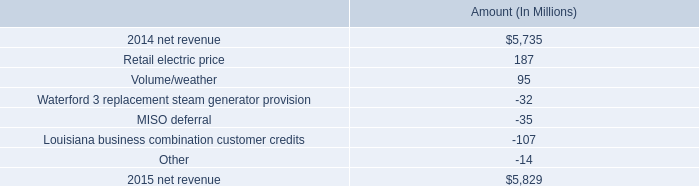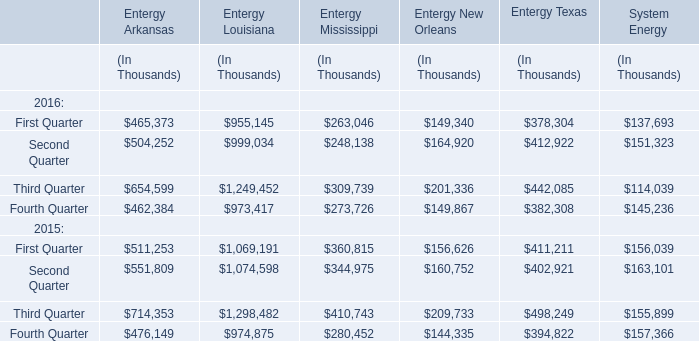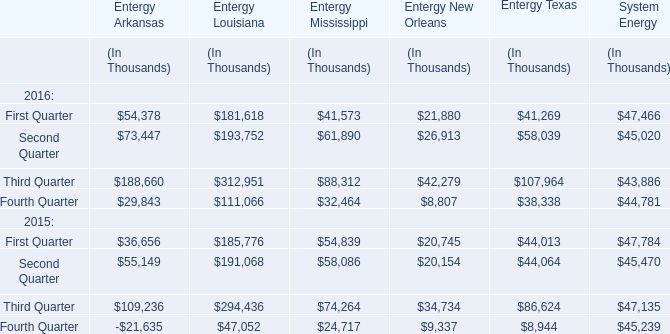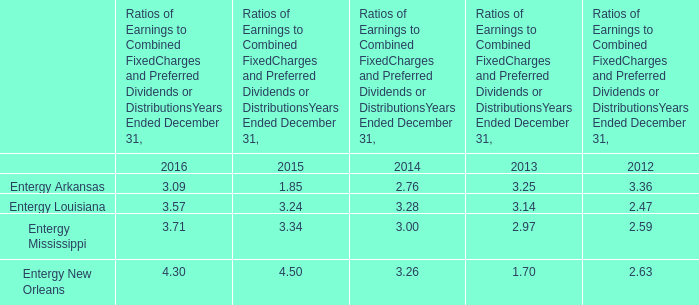Which year is Entergy Louisiana in Second Quarter the most? 
Answer: 2016. 